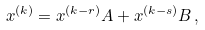<formula> <loc_0><loc_0><loc_500><loc_500>x ^ { ( k ) } = x ^ { ( k - r ) } A + x ^ { ( k - s ) } B \, ,</formula> 